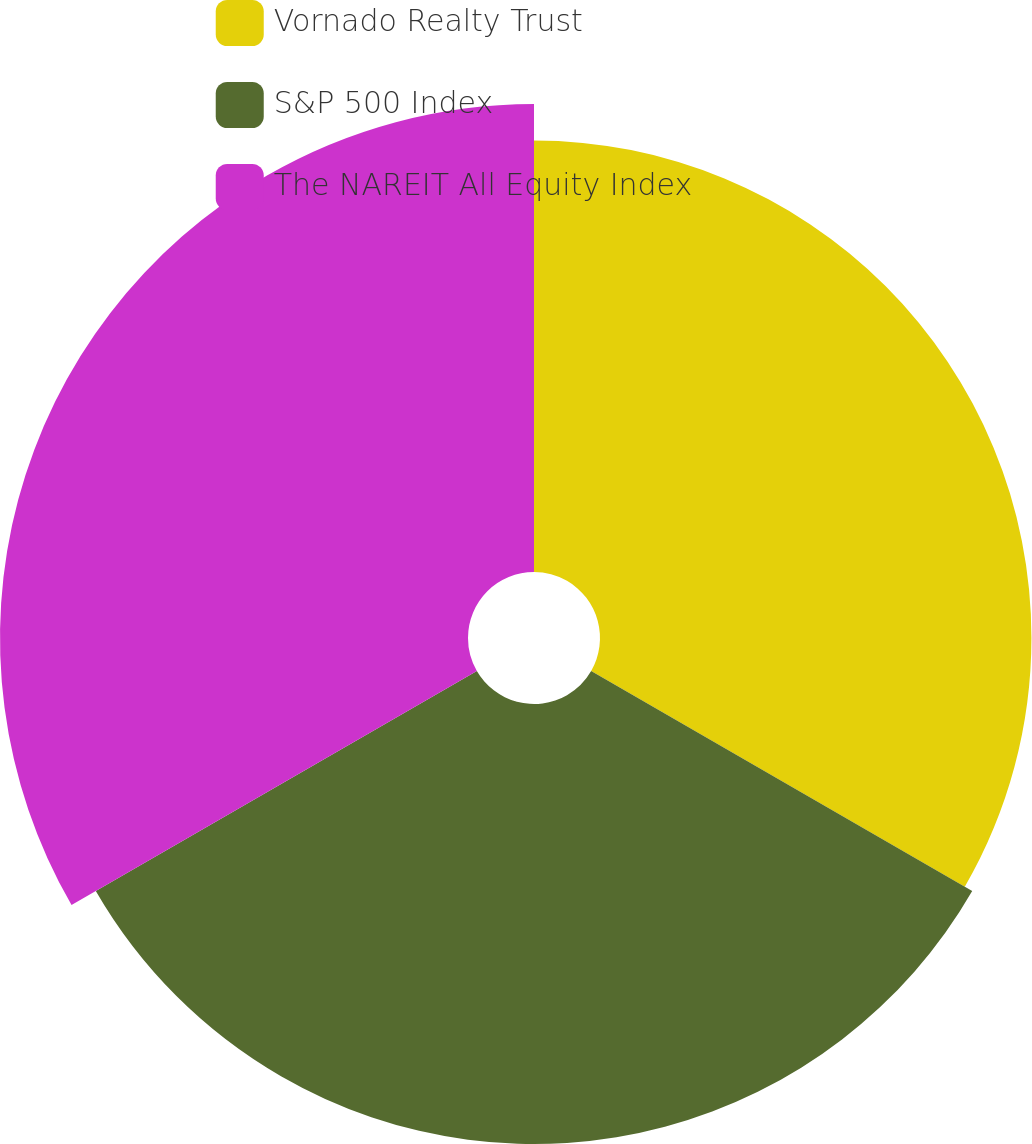Convert chart to OTSL. <chart><loc_0><loc_0><loc_500><loc_500><pie_chart><fcel>Vornado Realty Trust<fcel>S&P 500 Index<fcel>The NAREIT All Equity Index<nl><fcel>32.21%<fcel>32.85%<fcel>34.94%<nl></chart> 